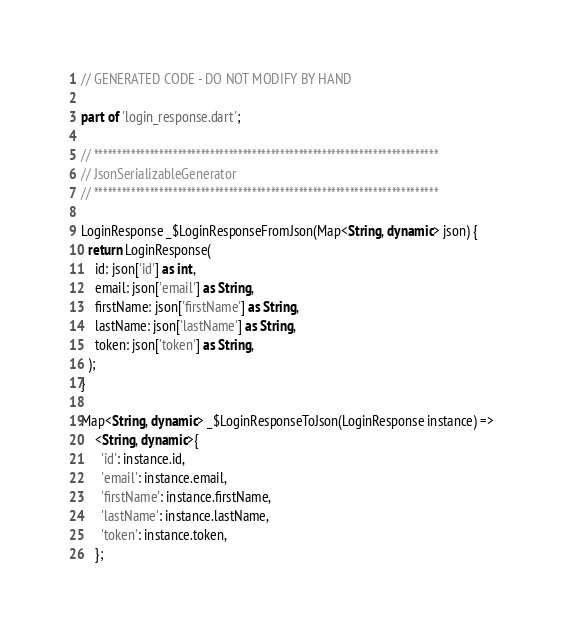Convert code to text. <code><loc_0><loc_0><loc_500><loc_500><_Dart_>// GENERATED CODE - DO NOT MODIFY BY HAND

part of 'login_response.dart';

// **************************************************************************
// JsonSerializableGenerator
// **************************************************************************

LoginResponse _$LoginResponseFromJson(Map<String, dynamic> json) {
  return LoginResponse(
    id: json['id'] as int,
    email: json['email'] as String,
    firstName: json['firstName'] as String,
    lastName: json['lastName'] as String,
    token: json['token'] as String,
  );
}

Map<String, dynamic> _$LoginResponseToJson(LoginResponse instance) =>
    <String, dynamic>{
      'id': instance.id,
      'email': instance.email,
      'firstName': instance.firstName,
      'lastName': instance.lastName,
      'token': instance.token,
    };
</code> 